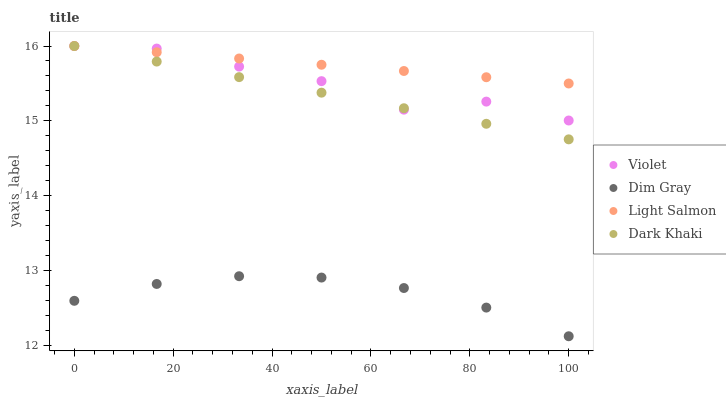Does Dim Gray have the minimum area under the curve?
Answer yes or no. Yes. Does Light Salmon have the maximum area under the curve?
Answer yes or no. Yes. Does Light Salmon have the minimum area under the curve?
Answer yes or no. No. Does Dim Gray have the maximum area under the curve?
Answer yes or no. No. Is Light Salmon the smoothest?
Answer yes or no. Yes. Is Violet the roughest?
Answer yes or no. Yes. Is Dim Gray the smoothest?
Answer yes or no. No. Is Dim Gray the roughest?
Answer yes or no. No. Does Dim Gray have the lowest value?
Answer yes or no. Yes. Does Light Salmon have the lowest value?
Answer yes or no. No. Does Violet have the highest value?
Answer yes or no. Yes. Does Dim Gray have the highest value?
Answer yes or no. No. Is Dim Gray less than Light Salmon?
Answer yes or no. Yes. Is Dark Khaki greater than Dim Gray?
Answer yes or no. Yes. Does Dark Khaki intersect Violet?
Answer yes or no. Yes. Is Dark Khaki less than Violet?
Answer yes or no. No. Is Dark Khaki greater than Violet?
Answer yes or no. No. Does Dim Gray intersect Light Salmon?
Answer yes or no. No. 